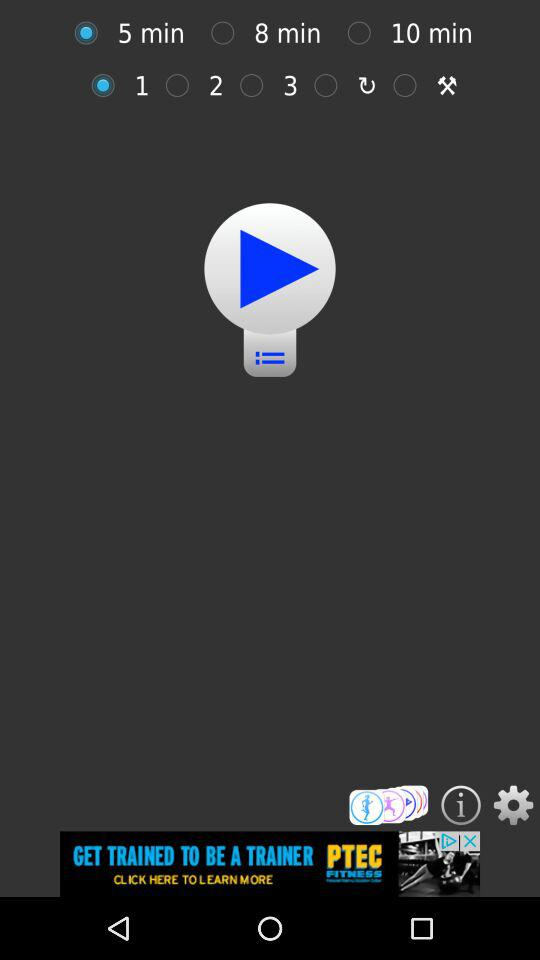What time duration is selected? The selected time duration is 5 minutes. 